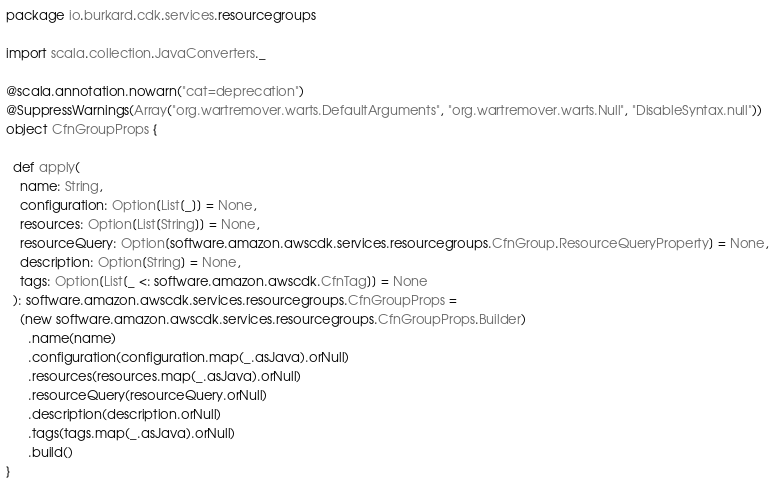<code> <loc_0><loc_0><loc_500><loc_500><_Scala_>package io.burkard.cdk.services.resourcegroups

import scala.collection.JavaConverters._

@scala.annotation.nowarn("cat=deprecation")
@SuppressWarnings(Array("org.wartremover.warts.DefaultArguments", "org.wartremover.warts.Null", "DisableSyntax.null"))
object CfnGroupProps {

  def apply(
    name: String,
    configuration: Option[List[_]] = None,
    resources: Option[List[String]] = None,
    resourceQuery: Option[software.amazon.awscdk.services.resourcegroups.CfnGroup.ResourceQueryProperty] = None,
    description: Option[String] = None,
    tags: Option[List[_ <: software.amazon.awscdk.CfnTag]] = None
  ): software.amazon.awscdk.services.resourcegroups.CfnGroupProps =
    (new software.amazon.awscdk.services.resourcegroups.CfnGroupProps.Builder)
      .name(name)
      .configuration(configuration.map(_.asJava).orNull)
      .resources(resources.map(_.asJava).orNull)
      .resourceQuery(resourceQuery.orNull)
      .description(description.orNull)
      .tags(tags.map(_.asJava).orNull)
      .build()
}
</code> 